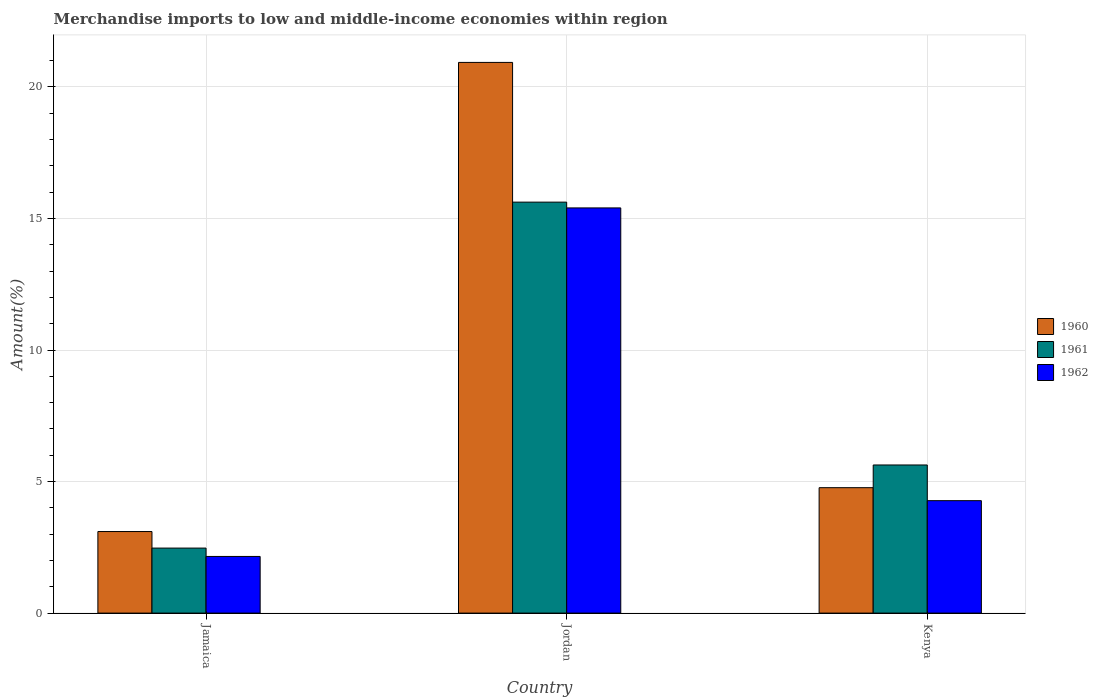How many different coloured bars are there?
Offer a terse response. 3. How many groups of bars are there?
Give a very brief answer. 3. Are the number of bars per tick equal to the number of legend labels?
Provide a short and direct response. Yes. Are the number of bars on each tick of the X-axis equal?
Provide a short and direct response. Yes. How many bars are there on the 3rd tick from the right?
Give a very brief answer. 3. What is the label of the 2nd group of bars from the left?
Provide a succinct answer. Jordan. In how many cases, is the number of bars for a given country not equal to the number of legend labels?
Keep it short and to the point. 0. What is the percentage of amount earned from merchandise imports in 1960 in Kenya?
Offer a terse response. 4.77. Across all countries, what is the maximum percentage of amount earned from merchandise imports in 1960?
Offer a very short reply. 20.93. Across all countries, what is the minimum percentage of amount earned from merchandise imports in 1962?
Provide a short and direct response. 2.15. In which country was the percentage of amount earned from merchandise imports in 1960 maximum?
Your answer should be compact. Jordan. In which country was the percentage of amount earned from merchandise imports in 1962 minimum?
Ensure brevity in your answer.  Jamaica. What is the total percentage of amount earned from merchandise imports in 1960 in the graph?
Offer a terse response. 28.8. What is the difference between the percentage of amount earned from merchandise imports in 1962 in Jordan and that in Kenya?
Provide a short and direct response. 11.13. What is the difference between the percentage of amount earned from merchandise imports in 1962 in Jamaica and the percentage of amount earned from merchandise imports in 1961 in Kenya?
Your answer should be very brief. -3.48. What is the average percentage of amount earned from merchandise imports in 1961 per country?
Make the answer very short. 7.91. What is the difference between the percentage of amount earned from merchandise imports of/in 1961 and percentage of amount earned from merchandise imports of/in 1962 in Kenya?
Your answer should be very brief. 1.36. What is the ratio of the percentage of amount earned from merchandise imports in 1961 in Jordan to that in Kenya?
Your response must be concise. 2.77. Is the percentage of amount earned from merchandise imports in 1960 in Jordan less than that in Kenya?
Ensure brevity in your answer.  No. Is the difference between the percentage of amount earned from merchandise imports in 1961 in Jordan and Kenya greater than the difference between the percentage of amount earned from merchandise imports in 1962 in Jordan and Kenya?
Your response must be concise. No. What is the difference between the highest and the second highest percentage of amount earned from merchandise imports in 1961?
Give a very brief answer. -3.16. What is the difference between the highest and the lowest percentage of amount earned from merchandise imports in 1960?
Offer a very short reply. 17.83. Is the sum of the percentage of amount earned from merchandise imports in 1961 in Jamaica and Kenya greater than the maximum percentage of amount earned from merchandise imports in 1962 across all countries?
Offer a very short reply. No. What does the 1st bar from the left in Jamaica represents?
Offer a terse response. 1960. What does the 2nd bar from the right in Jamaica represents?
Offer a very short reply. 1961. Is it the case that in every country, the sum of the percentage of amount earned from merchandise imports in 1961 and percentage of amount earned from merchandise imports in 1962 is greater than the percentage of amount earned from merchandise imports in 1960?
Offer a terse response. Yes. How many countries are there in the graph?
Ensure brevity in your answer.  3. Does the graph contain any zero values?
Your response must be concise. No. How many legend labels are there?
Your answer should be very brief. 3. What is the title of the graph?
Make the answer very short. Merchandise imports to low and middle-income economies within region. Does "1978" appear as one of the legend labels in the graph?
Provide a short and direct response. No. What is the label or title of the Y-axis?
Your response must be concise. Amount(%). What is the Amount(%) of 1960 in Jamaica?
Offer a very short reply. 3.1. What is the Amount(%) in 1961 in Jamaica?
Keep it short and to the point. 2.47. What is the Amount(%) in 1962 in Jamaica?
Your answer should be compact. 2.15. What is the Amount(%) in 1960 in Jordan?
Ensure brevity in your answer.  20.93. What is the Amount(%) of 1961 in Jordan?
Your answer should be very brief. 15.62. What is the Amount(%) of 1962 in Jordan?
Provide a short and direct response. 15.4. What is the Amount(%) of 1960 in Kenya?
Provide a succinct answer. 4.77. What is the Amount(%) in 1961 in Kenya?
Provide a succinct answer. 5.63. What is the Amount(%) in 1962 in Kenya?
Provide a short and direct response. 4.27. Across all countries, what is the maximum Amount(%) of 1960?
Provide a succinct answer. 20.93. Across all countries, what is the maximum Amount(%) in 1961?
Ensure brevity in your answer.  15.62. Across all countries, what is the maximum Amount(%) of 1962?
Make the answer very short. 15.4. Across all countries, what is the minimum Amount(%) in 1960?
Provide a short and direct response. 3.1. Across all countries, what is the minimum Amount(%) in 1961?
Provide a succinct answer. 2.47. Across all countries, what is the minimum Amount(%) in 1962?
Make the answer very short. 2.15. What is the total Amount(%) of 1960 in the graph?
Provide a short and direct response. 28.8. What is the total Amount(%) of 1961 in the graph?
Give a very brief answer. 23.72. What is the total Amount(%) in 1962 in the graph?
Make the answer very short. 21.83. What is the difference between the Amount(%) in 1960 in Jamaica and that in Jordan?
Your answer should be very brief. -17.83. What is the difference between the Amount(%) in 1961 in Jamaica and that in Jordan?
Offer a terse response. -13.15. What is the difference between the Amount(%) in 1962 in Jamaica and that in Jordan?
Provide a short and direct response. -13.25. What is the difference between the Amount(%) of 1960 in Jamaica and that in Kenya?
Your answer should be compact. -1.67. What is the difference between the Amount(%) of 1961 in Jamaica and that in Kenya?
Offer a terse response. -3.16. What is the difference between the Amount(%) of 1962 in Jamaica and that in Kenya?
Keep it short and to the point. -2.12. What is the difference between the Amount(%) in 1960 in Jordan and that in Kenya?
Give a very brief answer. 16.17. What is the difference between the Amount(%) in 1961 in Jordan and that in Kenya?
Ensure brevity in your answer.  9.99. What is the difference between the Amount(%) in 1962 in Jordan and that in Kenya?
Offer a terse response. 11.13. What is the difference between the Amount(%) in 1960 in Jamaica and the Amount(%) in 1961 in Jordan?
Your answer should be compact. -12.52. What is the difference between the Amount(%) of 1960 in Jamaica and the Amount(%) of 1962 in Jordan?
Keep it short and to the point. -12.3. What is the difference between the Amount(%) of 1961 in Jamaica and the Amount(%) of 1962 in Jordan?
Offer a terse response. -12.93. What is the difference between the Amount(%) of 1960 in Jamaica and the Amount(%) of 1961 in Kenya?
Ensure brevity in your answer.  -2.53. What is the difference between the Amount(%) in 1960 in Jamaica and the Amount(%) in 1962 in Kenya?
Ensure brevity in your answer.  -1.17. What is the difference between the Amount(%) in 1961 in Jamaica and the Amount(%) in 1962 in Kenya?
Your response must be concise. -1.8. What is the difference between the Amount(%) in 1960 in Jordan and the Amount(%) in 1961 in Kenya?
Provide a short and direct response. 15.3. What is the difference between the Amount(%) of 1960 in Jordan and the Amount(%) of 1962 in Kenya?
Provide a succinct answer. 16.66. What is the difference between the Amount(%) in 1961 in Jordan and the Amount(%) in 1962 in Kenya?
Provide a short and direct response. 11.35. What is the average Amount(%) of 1960 per country?
Your response must be concise. 9.6. What is the average Amount(%) of 1961 per country?
Your answer should be very brief. 7.91. What is the average Amount(%) of 1962 per country?
Provide a short and direct response. 7.28. What is the difference between the Amount(%) of 1960 and Amount(%) of 1961 in Jamaica?
Offer a very short reply. 0.63. What is the difference between the Amount(%) of 1960 and Amount(%) of 1962 in Jamaica?
Your answer should be compact. 0.95. What is the difference between the Amount(%) of 1961 and Amount(%) of 1962 in Jamaica?
Your response must be concise. 0.32. What is the difference between the Amount(%) of 1960 and Amount(%) of 1961 in Jordan?
Offer a terse response. 5.31. What is the difference between the Amount(%) in 1960 and Amount(%) in 1962 in Jordan?
Keep it short and to the point. 5.53. What is the difference between the Amount(%) in 1961 and Amount(%) in 1962 in Jordan?
Your answer should be compact. 0.22. What is the difference between the Amount(%) in 1960 and Amount(%) in 1961 in Kenya?
Make the answer very short. -0.86. What is the difference between the Amount(%) of 1960 and Amount(%) of 1962 in Kenya?
Your response must be concise. 0.49. What is the difference between the Amount(%) of 1961 and Amount(%) of 1962 in Kenya?
Give a very brief answer. 1.36. What is the ratio of the Amount(%) in 1960 in Jamaica to that in Jordan?
Make the answer very short. 0.15. What is the ratio of the Amount(%) in 1961 in Jamaica to that in Jordan?
Ensure brevity in your answer.  0.16. What is the ratio of the Amount(%) in 1962 in Jamaica to that in Jordan?
Your answer should be compact. 0.14. What is the ratio of the Amount(%) of 1960 in Jamaica to that in Kenya?
Offer a very short reply. 0.65. What is the ratio of the Amount(%) of 1961 in Jamaica to that in Kenya?
Your response must be concise. 0.44. What is the ratio of the Amount(%) in 1962 in Jamaica to that in Kenya?
Offer a very short reply. 0.5. What is the ratio of the Amount(%) in 1960 in Jordan to that in Kenya?
Make the answer very short. 4.39. What is the ratio of the Amount(%) in 1961 in Jordan to that in Kenya?
Your answer should be very brief. 2.77. What is the ratio of the Amount(%) in 1962 in Jordan to that in Kenya?
Offer a very short reply. 3.6. What is the difference between the highest and the second highest Amount(%) in 1960?
Provide a short and direct response. 16.17. What is the difference between the highest and the second highest Amount(%) in 1961?
Keep it short and to the point. 9.99. What is the difference between the highest and the second highest Amount(%) of 1962?
Keep it short and to the point. 11.13. What is the difference between the highest and the lowest Amount(%) of 1960?
Offer a terse response. 17.83. What is the difference between the highest and the lowest Amount(%) in 1961?
Your response must be concise. 13.15. What is the difference between the highest and the lowest Amount(%) of 1962?
Offer a very short reply. 13.25. 